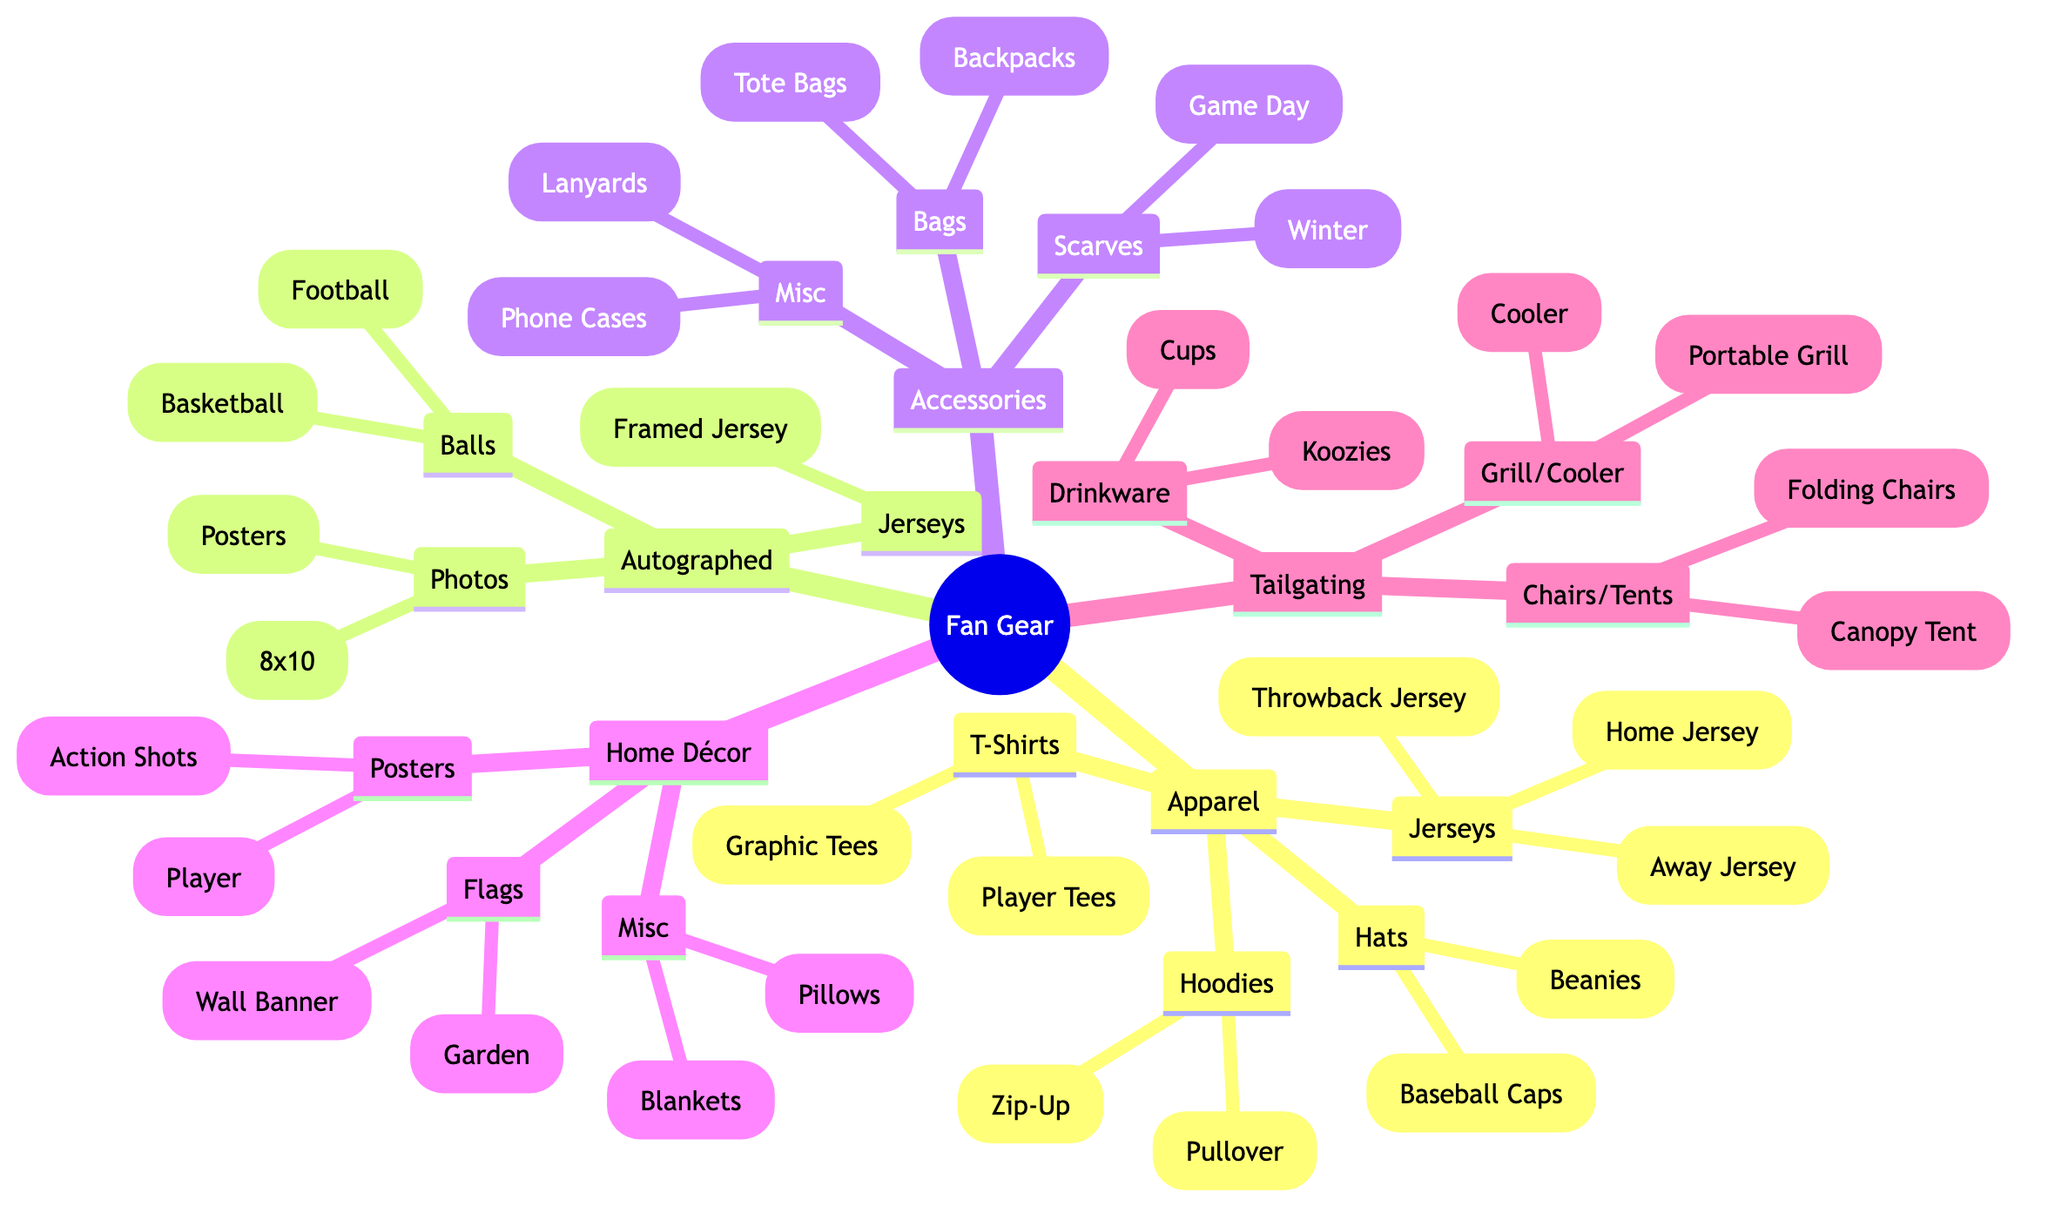What are the types of apparel listed in the diagram? The diagram shows five types of apparel: Jerseys, T-Shirts, Hoodies, Hats, and Accessories. These are all the main categories under Apparel.
Answer: Jerseys, T-Shirts, Hoodies, Hats, Accessories How many types of autographed merchandise are there? The diagram indicates that there are three types of autographed merchandise: Balls, Photos, and Jerseys. This is a direct count of the main nodes under Autographed Merchandise.
Answer: 3 What is the name of the item listed under 'Home Décor' that is not a flag or a poster? The item under Home Décor that is not a flag or a poster is the 'Miscellaneous' section. Within that section is the 'Buffalo Bulls Fleece Blanket', which fits the criteria given.
Answer: Buffalo Bulls Fleece Blanket Which accessory type includes items for carrying personal belongings? The 'Bags' category under Accessories includes items for carrying personal belongings, specifically 'Backpacks' and 'Tote Bags'. This category explicitly relates to carrying and storage.
Answer: Bags Identify an item associated with tailgating. The diagram lists multiple items associated with tailgating; one example is the 'Buffalo Bulls Portable Grill'. This is a direct reference from the Tailgating Supplies section.
Answer: Buffalo Bulls Portable Grill What color scheme is used for the 2023 Away Jersey? The 2023 Away Jersey is described as 'White and Blue' in the Apparel section. This requires identifying the specific item under Jerseys and noting the color description.
Answer: White and Blue How many different types of drinkware are listed under Tailgating Supplies? The Tailgating Supplies' Drinkware section includes two types: Cups and Koozies. Thus, the count of different items in this specific category is two.
Answer: 2 Which section of the diagram includes items related to winter sports? The 'Scarves' section under Accessories includes items like the 'Buffalo Bulls Winter Beanie', indicating its relation to winter sports and cold weather gear. Specifically, winter items are categorized here.
Answer: Scarves What type of jersey is mentioned under Autographed Merchandise? The type of jersey mentioned under Autographed Merchandise is the 'Framed Autographed Khalil Mack Jersey'. This is found by reviewing the specific node under the Autographed Jerseys category.
Answer: Framed Autographed Khalil Mack Jersey 